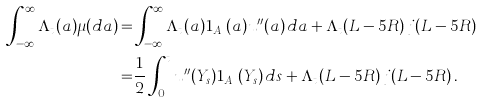<formula> <loc_0><loc_0><loc_500><loc_500>\int _ { - \infty } ^ { \infty } \Lambda _ { t } ( a ) \mu ( d a ) = & \int _ { - \infty } ^ { \infty } \Lambda _ { t } ( a ) { 1 } _ { A ^ { c } } ( a ) u ^ { \prime \prime } ( a ) \, d a + \Lambda _ { t } ( L - 5 R ) \, j ( L - 5 R ) \\ = & \frac { 1 } { 2 } \int _ { 0 } ^ { t } u ^ { \prime \prime } ( Y _ { s } ) { 1 } _ { A ^ { c } } ( Y _ { s } ) \, d s + \Lambda _ { t } ( L - 5 R ) \, j ( L - 5 R ) \, .</formula> 